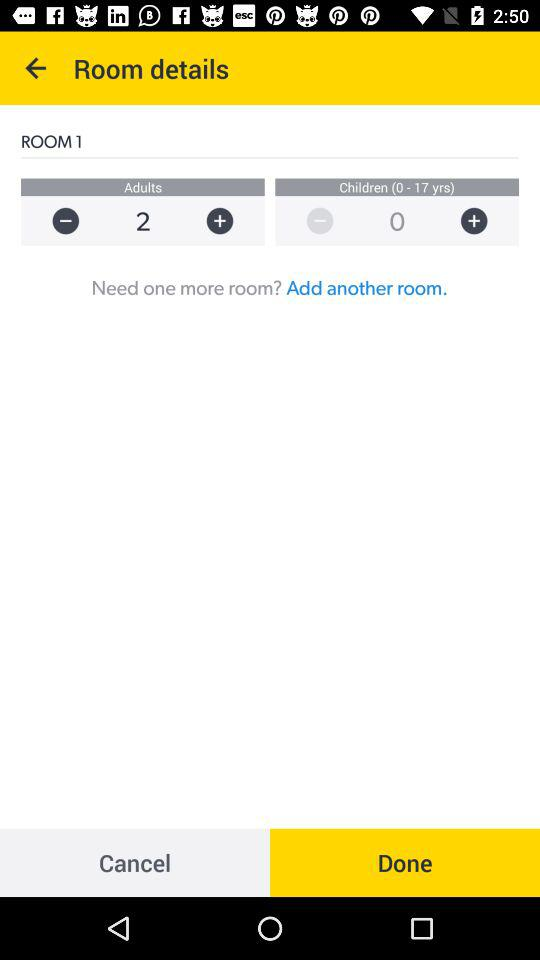How many more adults than children are in this room?
Answer the question using a single word or phrase. 2 